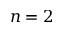<formula> <loc_0><loc_0><loc_500><loc_500>n = 2</formula> 